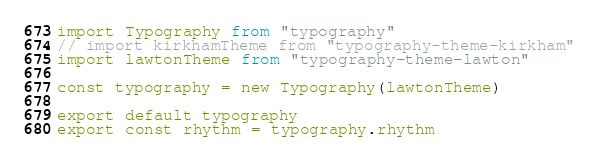<code> <loc_0><loc_0><loc_500><loc_500><_JavaScript_>import Typography from "typography"
// import kirkhamTheme from "typography-theme-kirkham"
import lawtonTheme from "typography-theme-lawton"

const typography = new Typography(lawtonTheme)

export default typography
export const rhythm = typography.rhythm
</code> 